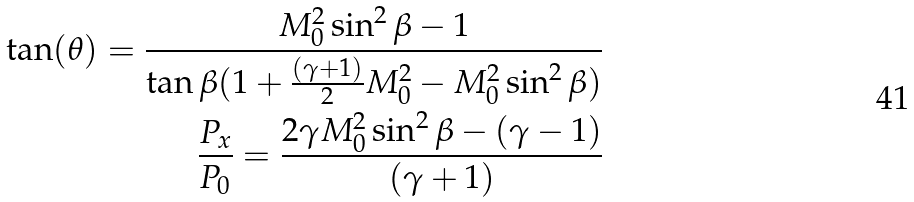Convert formula to latex. <formula><loc_0><loc_0><loc_500><loc_500>\tan ( \theta ) = \frac { M _ { 0 } ^ { 2 } \sin ^ { 2 } \beta - 1 } { \tan \beta ( 1 + \frac { ( \gamma + 1 ) } { 2 } M _ { 0 } ^ { 2 } - M _ { 0 } ^ { 2 } \sin ^ { 2 } \beta ) } \\ \frac { P _ { x } } { P _ { 0 } } = \frac { 2 \gamma M _ { 0 } ^ { 2 } \sin ^ { 2 } \beta - ( \gamma - 1 ) } { ( \gamma + 1 ) }</formula> 